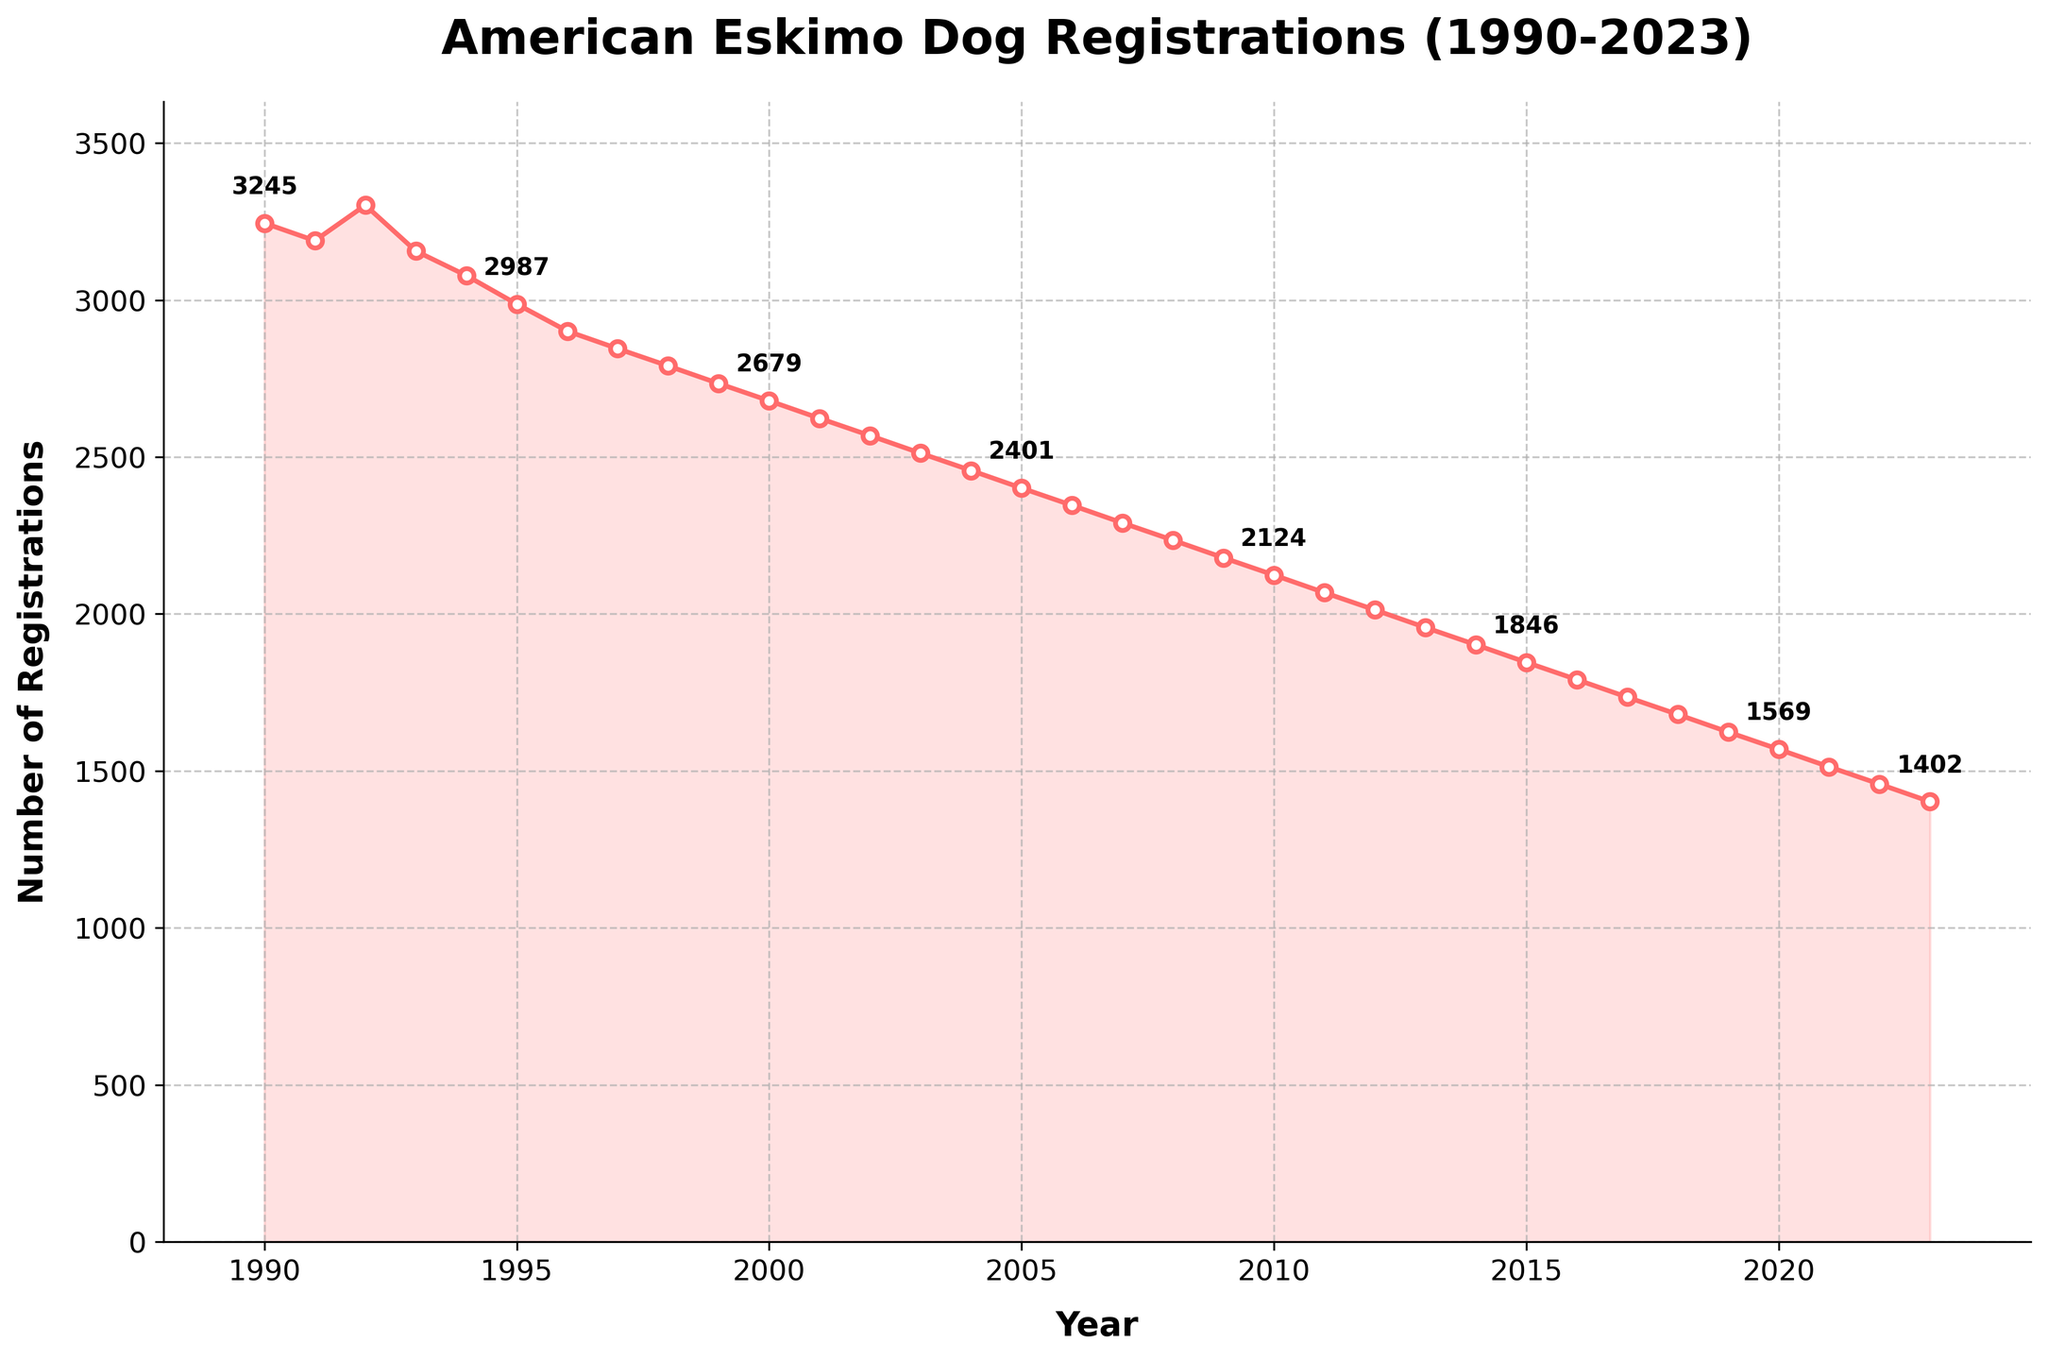What's the total number of registrations from 1990 to 1995? Add the number of registrations for each year from 1990 to 1995: 3245 + 3189 + 3302 + 3156 + 3078 + 2987 = 18957
Answer: 18957 In what year did the registrations first drop below 3000? By examining the trend, we see registrations drop below 3000 for the first time in 1995.
Answer: 1995 What has been the general trend in registrations from 1990 to 2023? The trend line from 1990 to 2023 shows a consistent decline in the number of registrations over this period.
Answer: Decline Which year had the lowest number of registrations? Look for the year with the smallest registration number; 2023 had the lowest with 1402 registrations.
Answer: 2023 How much did registrations decrease from 1990 to 2023? Subtract the registrations in 2023 from those in 1990: 3245 - 1402 = 1843
Answer: 1843 What is the average number of registrations per year from 1990 to 2023? Sum up all registration numbers from 1990 to 2023 and divide by the number of years (34): (total sum) / 34
Answer: 2258 Were there any periods where registrations increased? Which years? From the trend line, registrations increased from 1991 to 1992 and 1994 to 1995.
Answer: 1991-1992, 1994-1995 What is the percentage decrease in registrations from 2000 to 2023? Calculate the percentage decrease: ((2679 - 1402) / 2679) * 100 ≈ 47.66%
Answer: 47.66% How many years experienced a registration number above 3000? Count the number of years where the registrations exceeded 3000: 1990, 1991, 1992, 1993, and 1994.
Answer: 5 By how much did registrations decrease from 1998 to 1999? Subtract the registrations in 1999 from those in 1998: 2790 - 2734 = 56
Answer: 56 